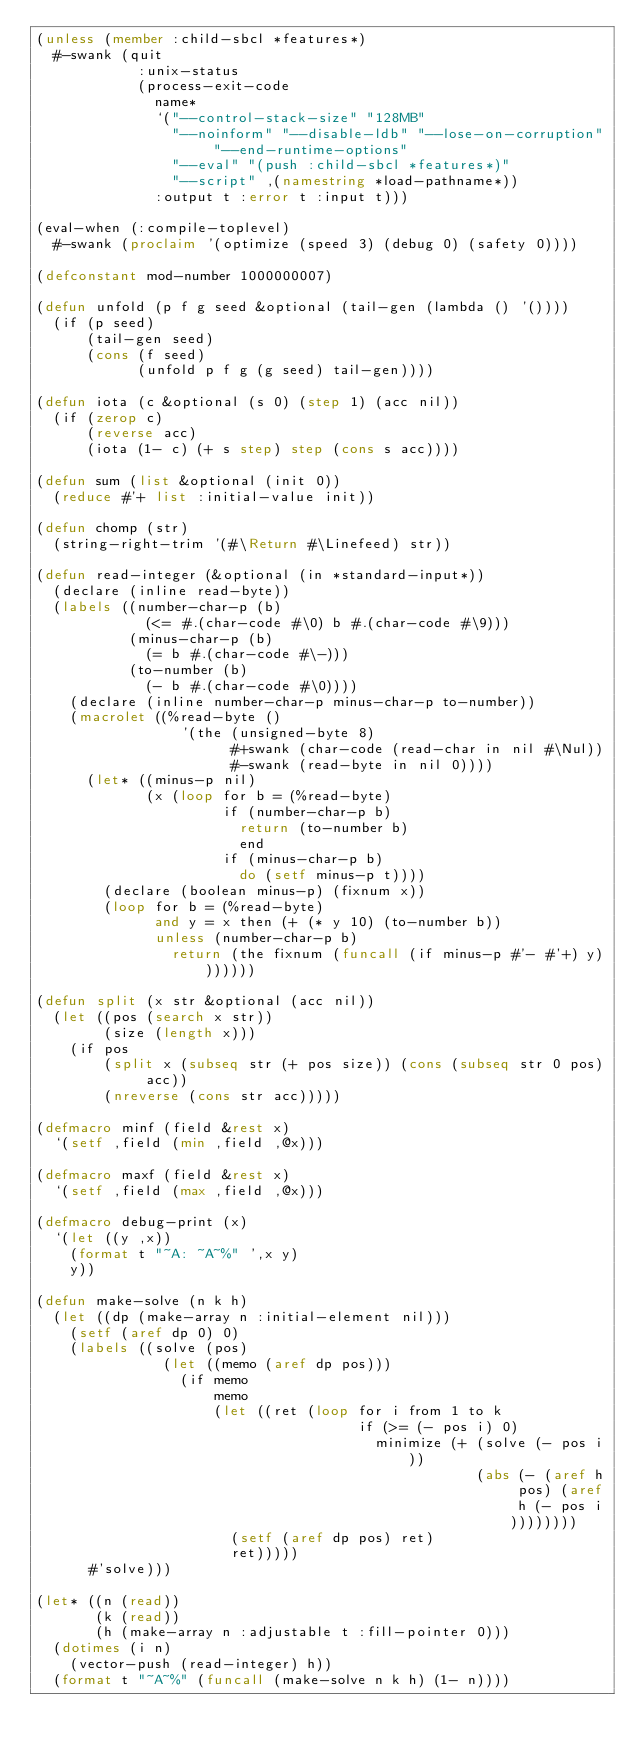Convert code to text. <code><loc_0><loc_0><loc_500><loc_500><_Lisp_>(unless (member :child-sbcl *features*)
  #-swank (quit
            :unix-status
            (process-exit-code
              name*
              `("--control-stack-size" "128MB"
                "--noinform" "--disable-ldb" "--lose-on-corruption" "--end-runtime-options"
                "--eval" "(push :child-sbcl *features*)"
                "--script" ,(namestring *load-pathname*))
              :output t :error t :input t)))

(eval-when (:compile-toplevel)
  #-swank (proclaim '(optimize (speed 3) (debug 0) (safety 0))))

(defconstant mod-number 1000000007)

(defun unfold (p f g seed &optional (tail-gen (lambda () '())))
  (if (p seed)
      (tail-gen seed)
      (cons (f seed)
            (unfold p f g (g seed) tail-gen))))

(defun iota (c &optional (s 0) (step 1) (acc nil))
  (if (zerop c)
      (reverse acc)
      (iota (1- c) (+ s step) step (cons s acc))))

(defun sum (list &optional (init 0))
  (reduce #'+ list :initial-value init))

(defun chomp (str)
  (string-right-trim '(#\Return #\Linefeed) str))

(defun read-integer (&optional (in *standard-input*))
  (declare (inline read-byte))
  (labels ((number-char-p (b)
             (<= #.(char-code #\0) b #.(char-code #\9)))
           (minus-char-p (b)
             (= b #.(char-code #\-)))
           (to-number (b)
             (- b #.(char-code #\0))))
    (declare (inline number-char-p minus-char-p to-number))
    (macrolet ((%read-byte ()
                 '(the (unsigned-byte 8)
                       #+swank (char-code (read-char in nil #\Nul))
                       #-swank (read-byte in nil 0))))
      (let* ((minus-p nil)
             (x (loop for b = (%read-byte)
                      if (number-char-p b)
                        return (to-number b)
                        end
                      if (minus-char-p b)
                        do (setf minus-p t))))
        (declare (boolean minus-p) (fixnum x))
        (loop for b = (%read-byte)
              and y = x then (+ (* y 10) (to-number b))
              unless (number-char-p b)
                return (the fixnum (funcall (if minus-p #'- #'+) y)))))))

(defun split (x str &optional (acc nil))
  (let ((pos (search x str))
        (size (length x)))
    (if pos
        (split x (subseq str (+ pos size)) (cons (subseq str 0 pos) acc))
        (nreverse (cons str acc)))))

(defmacro minf (field &rest x)
  `(setf ,field (min ,field ,@x)))

(defmacro maxf (field &rest x)
  `(setf ,field (max ,field ,@x)))

(defmacro debug-print (x)
  `(let ((y ,x))
    (format t "~A: ~A~%" ',x y)
    y))

(defun make-solve (n k h)
  (let ((dp (make-array n :initial-element nil)))
    (setf (aref dp 0) 0)
    (labels ((solve (pos)
               (let ((memo (aref dp pos)))
                 (if memo
                     memo
                     (let ((ret (loop for i from 1 to k
                                      if (>= (- pos i) 0)
                                        minimize (+ (solve (- pos i))
                                                    (abs (- (aref h pos) (aref h (- pos i))))))))
                       (setf (aref dp pos) ret)
                       ret)))))
      #'solve)))

(let* ((n (read))
       (k (read))
       (h (make-array n :adjustable t :fill-pointer 0)))
  (dotimes (i n)
    (vector-push (read-integer) h))
  (format t "~A~%" (funcall (make-solve n k h) (1- n))))

</code> 